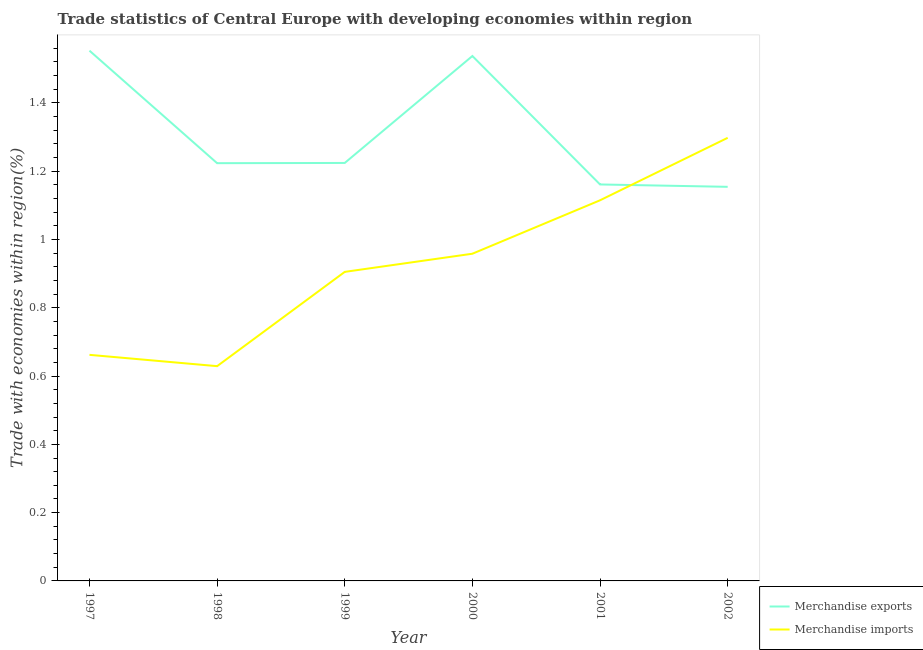How many different coloured lines are there?
Keep it short and to the point. 2. Does the line corresponding to merchandise exports intersect with the line corresponding to merchandise imports?
Offer a very short reply. Yes. Is the number of lines equal to the number of legend labels?
Provide a short and direct response. Yes. What is the merchandise exports in 2002?
Provide a short and direct response. 1.15. Across all years, what is the maximum merchandise imports?
Keep it short and to the point. 1.3. Across all years, what is the minimum merchandise imports?
Make the answer very short. 0.63. In which year was the merchandise imports maximum?
Ensure brevity in your answer.  2002. What is the total merchandise imports in the graph?
Offer a terse response. 5.57. What is the difference between the merchandise exports in 1997 and that in 2002?
Your response must be concise. 0.4. What is the difference between the merchandise exports in 1999 and the merchandise imports in 2001?
Make the answer very short. 0.11. What is the average merchandise imports per year?
Make the answer very short. 0.93. In the year 2000, what is the difference between the merchandise imports and merchandise exports?
Your answer should be very brief. -0.58. In how many years, is the merchandise imports greater than 1.3200000000000003 %?
Provide a short and direct response. 0. What is the ratio of the merchandise exports in 1998 to that in 1999?
Your answer should be very brief. 1. What is the difference between the highest and the second highest merchandise exports?
Offer a terse response. 0.02. What is the difference between the highest and the lowest merchandise imports?
Provide a short and direct response. 0.67. In how many years, is the merchandise imports greater than the average merchandise imports taken over all years?
Offer a very short reply. 3. Is the merchandise imports strictly less than the merchandise exports over the years?
Offer a very short reply. No. What is the difference between two consecutive major ticks on the Y-axis?
Offer a terse response. 0.2. How are the legend labels stacked?
Offer a very short reply. Vertical. What is the title of the graph?
Make the answer very short. Trade statistics of Central Europe with developing economies within region. Does "Nonresident" appear as one of the legend labels in the graph?
Give a very brief answer. No. What is the label or title of the X-axis?
Provide a short and direct response. Year. What is the label or title of the Y-axis?
Your answer should be very brief. Trade with economies within region(%). What is the Trade with economies within region(%) of Merchandise exports in 1997?
Offer a terse response. 1.55. What is the Trade with economies within region(%) of Merchandise imports in 1997?
Provide a short and direct response. 0.66. What is the Trade with economies within region(%) in Merchandise exports in 1998?
Offer a very short reply. 1.22. What is the Trade with economies within region(%) of Merchandise imports in 1998?
Your answer should be compact. 0.63. What is the Trade with economies within region(%) in Merchandise exports in 1999?
Provide a succinct answer. 1.22. What is the Trade with economies within region(%) of Merchandise imports in 1999?
Give a very brief answer. 0.91. What is the Trade with economies within region(%) of Merchandise exports in 2000?
Provide a short and direct response. 1.54. What is the Trade with economies within region(%) in Merchandise imports in 2000?
Provide a short and direct response. 0.96. What is the Trade with economies within region(%) of Merchandise exports in 2001?
Provide a short and direct response. 1.16. What is the Trade with economies within region(%) of Merchandise imports in 2001?
Your answer should be very brief. 1.11. What is the Trade with economies within region(%) of Merchandise exports in 2002?
Your answer should be compact. 1.15. What is the Trade with economies within region(%) of Merchandise imports in 2002?
Keep it short and to the point. 1.3. Across all years, what is the maximum Trade with economies within region(%) in Merchandise exports?
Offer a very short reply. 1.55. Across all years, what is the maximum Trade with economies within region(%) in Merchandise imports?
Give a very brief answer. 1.3. Across all years, what is the minimum Trade with economies within region(%) of Merchandise exports?
Give a very brief answer. 1.15. Across all years, what is the minimum Trade with economies within region(%) in Merchandise imports?
Ensure brevity in your answer.  0.63. What is the total Trade with economies within region(%) of Merchandise exports in the graph?
Provide a short and direct response. 7.85. What is the total Trade with economies within region(%) in Merchandise imports in the graph?
Give a very brief answer. 5.57. What is the difference between the Trade with economies within region(%) of Merchandise exports in 1997 and that in 1998?
Give a very brief answer. 0.33. What is the difference between the Trade with economies within region(%) of Merchandise imports in 1997 and that in 1998?
Give a very brief answer. 0.03. What is the difference between the Trade with economies within region(%) in Merchandise exports in 1997 and that in 1999?
Your answer should be compact. 0.33. What is the difference between the Trade with economies within region(%) in Merchandise imports in 1997 and that in 1999?
Make the answer very short. -0.24. What is the difference between the Trade with economies within region(%) of Merchandise exports in 1997 and that in 2000?
Give a very brief answer. 0.02. What is the difference between the Trade with economies within region(%) in Merchandise imports in 1997 and that in 2000?
Your answer should be compact. -0.3. What is the difference between the Trade with economies within region(%) in Merchandise exports in 1997 and that in 2001?
Make the answer very short. 0.39. What is the difference between the Trade with economies within region(%) in Merchandise imports in 1997 and that in 2001?
Offer a very short reply. -0.45. What is the difference between the Trade with economies within region(%) of Merchandise exports in 1997 and that in 2002?
Ensure brevity in your answer.  0.4. What is the difference between the Trade with economies within region(%) of Merchandise imports in 1997 and that in 2002?
Provide a succinct answer. -0.64. What is the difference between the Trade with economies within region(%) in Merchandise exports in 1998 and that in 1999?
Keep it short and to the point. -0. What is the difference between the Trade with economies within region(%) in Merchandise imports in 1998 and that in 1999?
Offer a terse response. -0.28. What is the difference between the Trade with economies within region(%) of Merchandise exports in 1998 and that in 2000?
Your response must be concise. -0.31. What is the difference between the Trade with economies within region(%) of Merchandise imports in 1998 and that in 2000?
Keep it short and to the point. -0.33. What is the difference between the Trade with economies within region(%) in Merchandise exports in 1998 and that in 2001?
Offer a terse response. 0.06. What is the difference between the Trade with economies within region(%) of Merchandise imports in 1998 and that in 2001?
Offer a very short reply. -0.49. What is the difference between the Trade with economies within region(%) of Merchandise exports in 1998 and that in 2002?
Provide a succinct answer. 0.07. What is the difference between the Trade with economies within region(%) in Merchandise imports in 1998 and that in 2002?
Your answer should be compact. -0.67. What is the difference between the Trade with economies within region(%) in Merchandise exports in 1999 and that in 2000?
Your answer should be compact. -0.31. What is the difference between the Trade with economies within region(%) in Merchandise imports in 1999 and that in 2000?
Provide a short and direct response. -0.05. What is the difference between the Trade with economies within region(%) of Merchandise exports in 1999 and that in 2001?
Ensure brevity in your answer.  0.06. What is the difference between the Trade with economies within region(%) in Merchandise imports in 1999 and that in 2001?
Your answer should be very brief. -0.21. What is the difference between the Trade with economies within region(%) of Merchandise exports in 1999 and that in 2002?
Keep it short and to the point. 0.07. What is the difference between the Trade with economies within region(%) in Merchandise imports in 1999 and that in 2002?
Ensure brevity in your answer.  -0.39. What is the difference between the Trade with economies within region(%) of Merchandise exports in 2000 and that in 2001?
Your response must be concise. 0.38. What is the difference between the Trade with economies within region(%) in Merchandise imports in 2000 and that in 2001?
Offer a very short reply. -0.16. What is the difference between the Trade with economies within region(%) in Merchandise exports in 2000 and that in 2002?
Offer a terse response. 0.38. What is the difference between the Trade with economies within region(%) in Merchandise imports in 2000 and that in 2002?
Make the answer very short. -0.34. What is the difference between the Trade with economies within region(%) in Merchandise exports in 2001 and that in 2002?
Your answer should be compact. 0.01. What is the difference between the Trade with economies within region(%) in Merchandise imports in 2001 and that in 2002?
Your response must be concise. -0.18. What is the difference between the Trade with economies within region(%) of Merchandise exports in 1997 and the Trade with economies within region(%) of Merchandise imports in 1998?
Give a very brief answer. 0.92. What is the difference between the Trade with economies within region(%) in Merchandise exports in 1997 and the Trade with economies within region(%) in Merchandise imports in 1999?
Ensure brevity in your answer.  0.65. What is the difference between the Trade with economies within region(%) of Merchandise exports in 1997 and the Trade with economies within region(%) of Merchandise imports in 2000?
Your answer should be compact. 0.59. What is the difference between the Trade with economies within region(%) of Merchandise exports in 1997 and the Trade with economies within region(%) of Merchandise imports in 2001?
Your response must be concise. 0.44. What is the difference between the Trade with economies within region(%) of Merchandise exports in 1997 and the Trade with economies within region(%) of Merchandise imports in 2002?
Your answer should be very brief. 0.26. What is the difference between the Trade with economies within region(%) of Merchandise exports in 1998 and the Trade with economies within region(%) of Merchandise imports in 1999?
Offer a very short reply. 0.32. What is the difference between the Trade with economies within region(%) in Merchandise exports in 1998 and the Trade with economies within region(%) in Merchandise imports in 2000?
Your answer should be very brief. 0.27. What is the difference between the Trade with economies within region(%) of Merchandise exports in 1998 and the Trade with economies within region(%) of Merchandise imports in 2001?
Your answer should be very brief. 0.11. What is the difference between the Trade with economies within region(%) of Merchandise exports in 1998 and the Trade with economies within region(%) of Merchandise imports in 2002?
Make the answer very short. -0.07. What is the difference between the Trade with economies within region(%) in Merchandise exports in 1999 and the Trade with economies within region(%) in Merchandise imports in 2000?
Your answer should be compact. 0.27. What is the difference between the Trade with economies within region(%) in Merchandise exports in 1999 and the Trade with economies within region(%) in Merchandise imports in 2001?
Give a very brief answer. 0.11. What is the difference between the Trade with economies within region(%) in Merchandise exports in 1999 and the Trade with economies within region(%) in Merchandise imports in 2002?
Offer a terse response. -0.07. What is the difference between the Trade with economies within region(%) of Merchandise exports in 2000 and the Trade with economies within region(%) of Merchandise imports in 2001?
Give a very brief answer. 0.42. What is the difference between the Trade with economies within region(%) of Merchandise exports in 2000 and the Trade with economies within region(%) of Merchandise imports in 2002?
Your answer should be compact. 0.24. What is the difference between the Trade with economies within region(%) of Merchandise exports in 2001 and the Trade with economies within region(%) of Merchandise imports in 2002?
Ensure brevity in your answer.  -0.14. What is the average Trade with economies within region(%) of Merchandise exports per year?
Your answer should be very brief. 1.31. What is the average Trade with economies within region(%) of Merchandise imports per year?
Provide a succinct answer. 0.93. In the year 1997, what is the difference between the Trade with economies within region(%) in Merchandise exports and Trade with economies within region(%) in Merchandise imports?
Keep it short and to the point. 0.89. In the year 1998, what is the difference between the Trade with economies within region(%) in Merchandise exports and Trade with economies within region(%) in Merchandise imports?
Your response must be concise. 0.59. In the year 1999, what is the difference between the Trade with economies within region(%) in Merchandise exports and Trade with economies within region(%) in Merchandise imports?
Provide a succinct answer. 0.32. In the year 2000, what is the difference between the Trade with economies within region(%) in Merchandise exports and Trade with economies within region(%) in Merchandise imports?
Your response must be concise. 0.58. In the year 2001, what is the difference between the Trade with economies within region(%) of Merchandise exports and Trade with economies within region(%) of Merchandise imports?
Provide a short and direct response. 0.05. In the year 2002, what is the difference between the Trade with economies within region(%) of Merchandise exports and Trade with economies within region(%) of Merchandise imports?
Keep it short and to the point. -0.14. What is the ratio of the Trade with economies within region(%) of Merchandise exports in 1997 to that in 1998?
Offer a very short reply. 1.27. What is the ratio of the Trade with economies within region(%) of Merchandise imports in 1997 to that in 1998?
Offer a terse response. 1.05. What is the ratio of the Trade with economies within region(%) of Merchandise exports in 1997 to that in 1999?
Offer a terse response. 1.27. What is the ratio of the Trade with economies within region(%) in Merchandise imports in 1997 to that in 1999?
Provide a succinct answer. 0.73. What is the ratio of the Trade with economies within region(%) in Merchandise exports in 1997 to that in 2000?
Your answer should be compact. 1.01. What is the ratio of the Trade with economies within region(%) in Merchandise imports in 1997 to that in 2000?
Offer a terse response. 0.69. What is the ratio of the Trade with economies within region(%) in Merchandise exports in 1997 to that in 2001?
Give a very brief answer. 1.34. What is the ratio of the Trade with economies within region(%) of Merchandise imports in 1997 to that in 2001?
Ensure brevity in your answer.  0.59. What is the ratio of the Trade with economies within region(%) in Merchandise exports in 1997 to that in 2002?
Your answer should be compact. 1.35. What is the ratio of the Trade with economies within region(%) of Merchandise imports in 1997 to that in 2002?
Your answer should be very brief. 0.51. What is the ratio of the Trade with economies within region(%) of Merchandise imports in 1998 to that in 1999?
Your response must be concise. 0.69. What is the ratio of the Trade with economies within region(%) in Merchandise exports in 1998 to that in 2000?
Your answer should be very brief. 0.8. What is the ratio of the Trade with economies within region(%) in Merchandise imports in 1998 to that in 2000?
Provide a succinct answer. 0.66. What is the ratio of the Trade with economies within region(%) of Merchandise exports in 1998 to that in 2001?
Your answer should be very brief. 1.05. What is the ratio of the Trade with economies within region(%) in Merchandise imports in 1998 to that in 2001?
Offer a terse response. 0.56. What is the ratio of the Trade with economies within region(%) of Merchandise exports in 1998 to that in 2002?
Provide a short and direct response. 1.06. What is the ratio of the Trade with economies within region(%) in Merchandise imports in 1998 to that in 2002?
Provide a succinct answer. 0.48. What is the ratio of the Trade with economies within region(%) in Merchandise exports in 1999 to that in 2000?
Your answer should be compact. 0.8. What is the ratio of the Trade with economies within region(%) in Merchandise imports in 1999 to that in 2000?
Offer a terse response. 0.94. What is the ratio of the Trade with economies within region(%) in Merchandise exports in 1999 to that in 2001?
Your answer should be very brief. 1.05. What is the ratio of the Trade with economies within region(%) of Merchandise imports in 1999 to that in 2001?
Your answer should be compact. 0.81. What is the ratio of the Trade with economies within region(%) of Merchandise exports in 1999 to that in 2002?
Provide a succinct answer. 1.06. What is the ratio of the Trade with economies within region(%) in Merchandise imports in 1999 to that in 2002?
Provide a short and direct response. 0.7. What is the ratio of the Trade with economies within region(%) in Merchandise exports in 2000 to that in 2001?
Your answer should be very brief. 1.32. What is the ratio of the Trade with economies within region(%) in Merchandise imports in 2000 to that in 2001?
Offer a very short reply. 0.86. What is the ratio of the Trade with economies within region(%) in Merchandise exports in 2000 to that in 2002?
Ensure brevity in your answer.  1.33. What is the ratio of the Trade with economies within region(%) of Merchandise imports in 2000 to that in 2002?
Provide a short and direct response. 0.74. What is the ratio of the Trade with economies within region(%) in Merchandise imports in 2001 to that in 2002?
Your response must be concise. 0.86. What is the difference between the highest and the second highest Trade with economies within region(%) in Merchandise exports?
Your answer should be compact. 0.02. What is the difference between the highest and the second highest Trade with economies within region(%) of Merchandise imports?
Your answer should be compact. 0.18. What is the difference between the highest and the lowest Trade with economies within region(%) in Merchandise exports?
Your response must be concise. 0.4. What is the difference between the highest and the lowest Trade with economies within region(%) in Merchandise imports?
Provide a short and direct response. 0.67. 